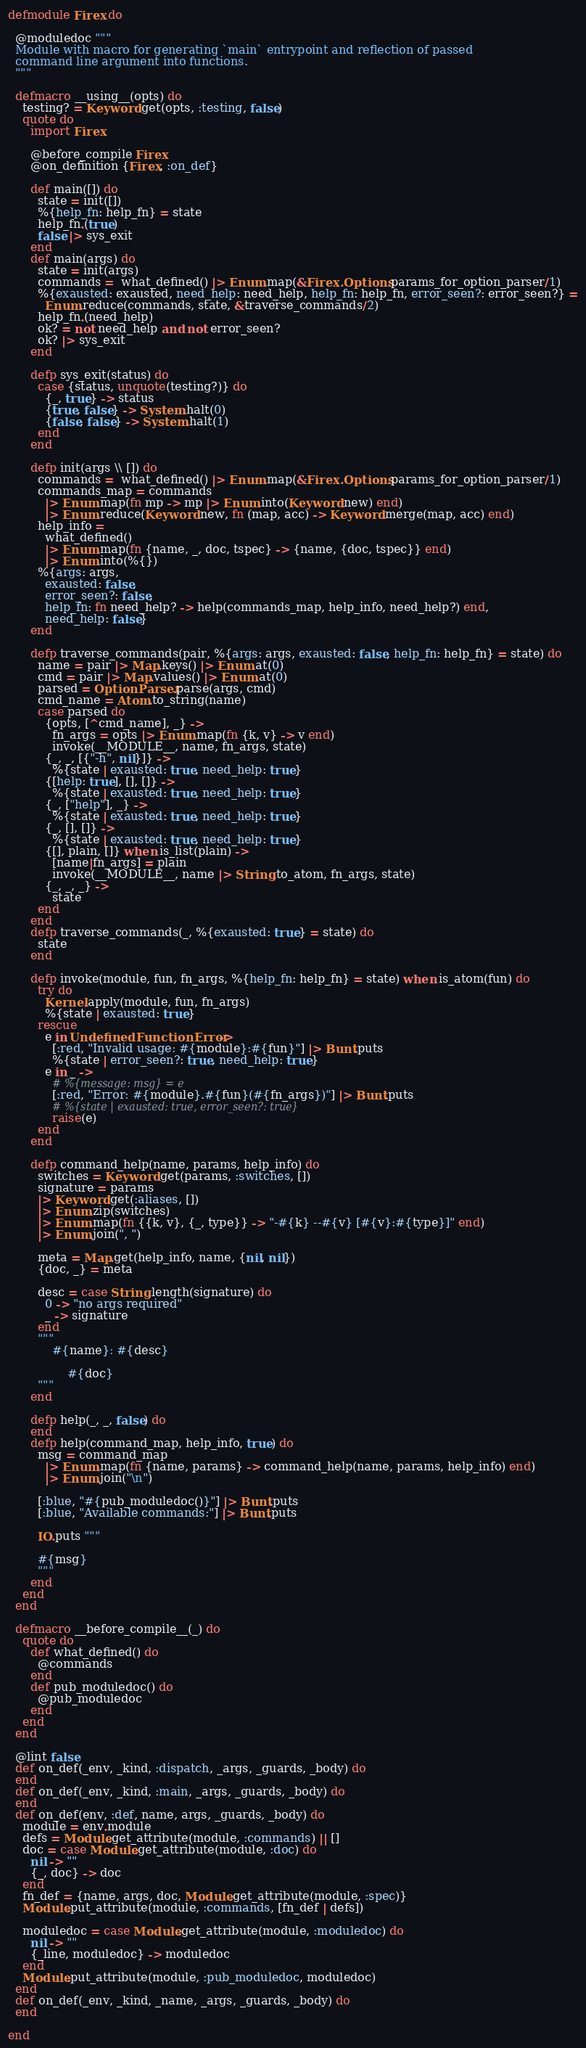<code> <loc_0><loc_0><loc_500><loc_500><_Elixir_>defmodule Firex do

  @moduledoc """
  Module with macro for generating `main` entrypoint and reflection of passed
  command line argument into functions.
  """

  defmacro __using__(opts) do
    testing? = Keyword.get(opts, :testing, false)
    quote do
      import Firex

      @before_compile Firex
      @on_definition {Firex, :on_def}

      def main([]) do
        state = init([])
        %{help_fn: help_fn} = state
        help_fn.(true)
        false |> sys_exit
      end
      def main(args) do
        state = init(args)
        commands =  what_defined() |> Enum.map(&Firex.Options.params_for_option_parser/1)
        %{exausted: exausted, need_help: need_help, help_fn: help_fn, error_seen?: error_seen?} =
          Enum.reduce(commands, state, &traverse_commands/2)
        help_fn.(need_help)
        ok? = not need_help and not error_seen?
        ok? |> sys_exit
      end

      defp sys_exit(status) do
        case {status, unquote(testing?)} do
          {_, true} -> status
          {true, false} -> System.halt(0)
          {false, false} -> System.halt(1)
        end
      end

      defp init(args \\ []) do
        commands =  what_defined() |> Enum.map(&Firex.Options.params_for_option_parser/1)
        commands_map = commands
          |> Enum.map(fn mp -> mp |> Enum.into(Keyword.new) end)
          |> Enum.reduce(Keyword.new, fn (map, acc) -> Keyword.merge(map, acc) end)
        help_info =
          what_defined()
          |> Enum.map(fn {name, _, doc, tspec} -> {name, {doc, tspec}} end)
          |> Enum.into(%{})
        %{args: args,
          exausted: false,
          error_seen?: false,
          help_fn: fn need_help? -> help(commands_map, help_info, need_help?) end,
          need_help: false}
      end

      defp traverse_commands(pair, %{args: args, exausted: false, help_fn: help_fn} = state) do
        name = pair |> Map.keys() |> Enum.at(0)
        cmd = pair |> Map.values() |> Enum.at(0)
        parsed = OptionParser.parse(args, cmd)
        cmd_name = Atom.to_string(name)
        case parsed do
          {opts, [^cmd_name], _} ->
            fn_args = opts |> Enum.map(fn {k, v} -> v end)
            invoke(__MODULE__, name, fn_args, state)
          {_, _, [{"-h", nil}]} ->
            %{state | exausted: true, need_help: true}
          {[help: true], [], []} ->
            %{state | exausted: true, need_help: true}
          {_, ["help"], _} ->
            %{state | exausted: true, need_help: true}
          {_, [], []} ->
            %{state | exausted: true, need_help: true}
          {[], plain, []} when is_list(plain) ->
            [name|fn_args] = plain
            invoke(__MODULE__, name |> String.to_atom, fn_args, state)
          {_, _, _} ->
            state
        end
      end
      defp traverse_commands(_, %{exausted: true} = state) do
        state
      end

      defp invoke(module, fun, fn_args, %{help_fn: help_fn} = state) when is_atom(fun) do
        try do
          Kernel.apply(module, fun, fn_args)
          %{state | exausted: true}
        rescue
          e in UndefinedFunctionError ->
            [:red, "Invalid usage: #{module}:#{fun}"] |> Bunt.puts
            %{state | error_seen?: true, need_help: true}
          e in _ ->
            # %{message: msg} = e
            [:red, "Error: #{module}.#{fun}(#{fn_args})"] |> Bunt.puts
            # %{state | exausted: true, error_seen?: true}
            raise(e)
        end
      end

      defp command_help(name, params, help_info) do
        switches = Keyword.get(params, :switches, [])
        signature = params
        |> Keyword.get(:aliases, [])
        |> Enum.zip(switches)
        |> Enum.map(fn {{k, v}, {_, type}} -> "-#{k} --#{v} [#{v}:#{type}]" end)
        |> Enum.join(", ")

        meta = Map.get(help_info, name, {nil, nil})
        {doc, _} = meta

        desc = case String.length(signature) do
          0 -> "no args required"
          _ -> signature
        end
        """
            #{name}: #{desc}

                #{doc}
        """
      end

      defp help(_, _, false) do
      end
      defp help(command_map, help_info, true) do
        msg = command_map
          |> Enum.map(fn {name, params} -> command_help(name, params, help_info) end)
          |> Enum.join("\n")

        [:blue, "#{pub_moduledoc()}"] |> Bunt.puts
        [:blue, "Available commands:"] |> Bunt.puts

        IO.puts """

        #{msg}
        """
      end
    end
  end

  defmacro __before_compile__(_) do
    quote do
      def what_defined() do
        @commands
      end
      def pub_moduledoc() do
        @pub_moduledoc
      end
    end
  end

  @lint false
  def on_def(_env, _kind, :dispatch, _args, _guards, _body) do
  end
  def on_def(_env, _kind, :main, _args, _guards, _body) do
  end
  def on_def(env, :def, name, args, _guards, _body) do
    module = env.module
    defs = Module.get_attribute(module, :commands) || []
    doc = case Module.get_attribute(module, :doc) do
      nil -> ""
      {_, doc} -> doc
    end
    fn_def = {name, args, doc, Module.get_attribute(module, :spec)}
    Module.put_attribute(module, :commands, [fn_def | defs])

    moduledoc = case Module.get_attribute(module, :moduledoc) do
      nil -> ""
      {_line, moduledoc} -> moduledoc
    end
    Module.put_attribute(module, :pub_moduledoc, moduledoc)
  end
  def on_def(_env, _kind, _name, _args, _guards, _body) do
  end

end
</code> 